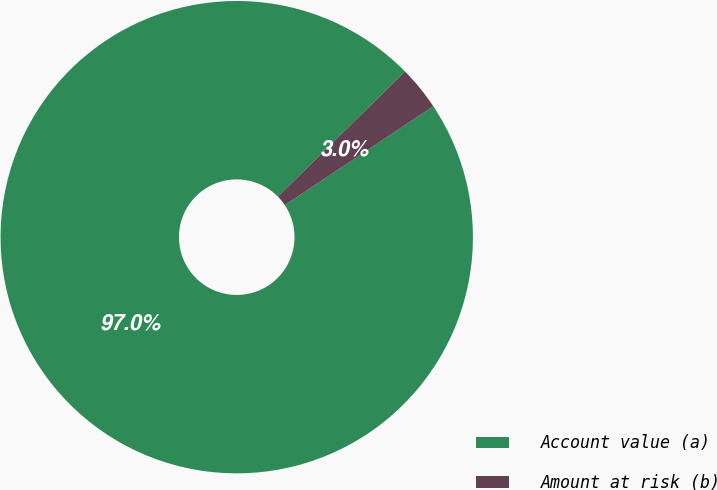Convert chart. <chart><loc_0><loc_0><loc_500><loc_500><pie_chart><fcel>Account value (a)<fcel>Amount at risk (b)<nl><fcel>96.97%<fcel>3.03%<nl></chart> 